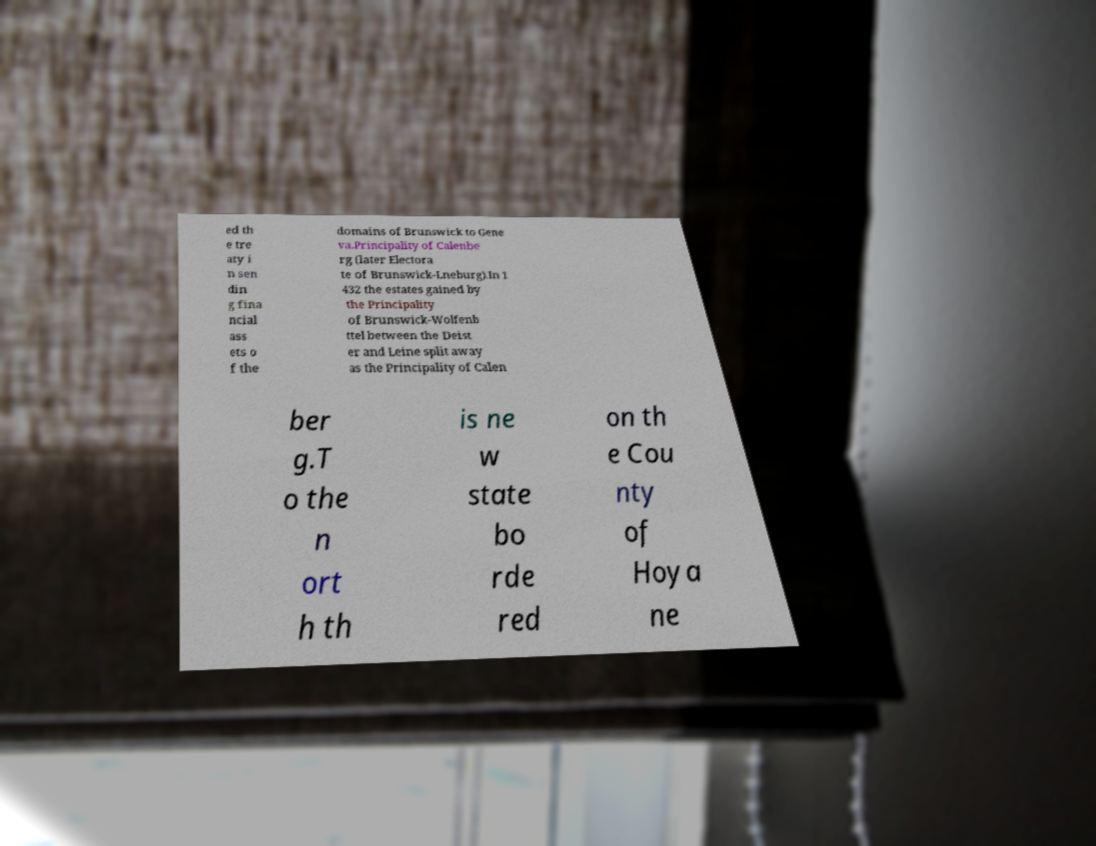I need the written content from this picture converted into text. Can you do that? ed th e tre aty i n sen din g fina ncial ass ets o f the domains of Brunswick to Gene va.Principality of Calenbe rg (later Electora te of Brunswick-Lneburg).In 1 432 the estates gained by the Principality of Brunswick-Wolfenb ttel between the Deist er and Leine split away as the Principality of Calen ber g.T o the n ort h th is ne w state bo rde red on th e Cou nty of Hoya ne 